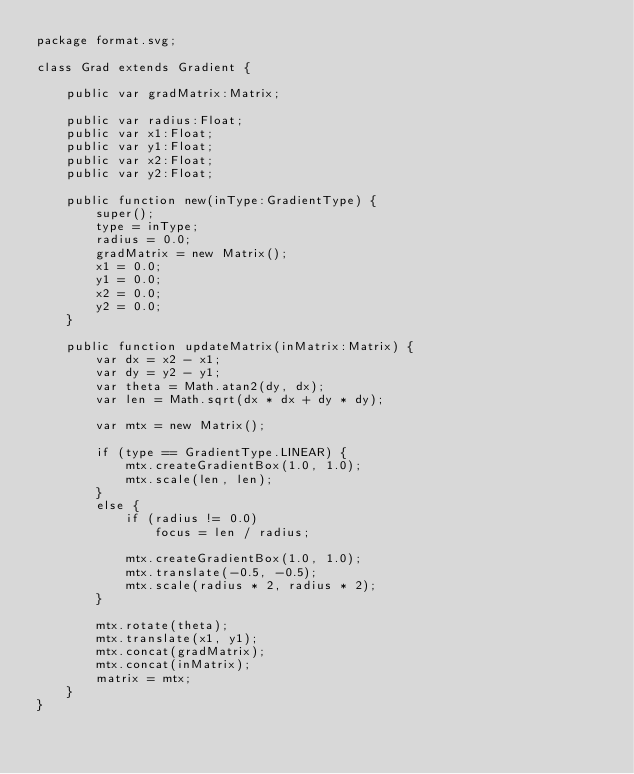Convert code to text. <code><loc_0><loc_0><loc_500><loc_500><_Haxe_>package format.svg;

class Grad extends Gradient {

	public var gradMatrix:Matrix;

	public var radius:Float;
	public var x1:Float;
	public var y1:Float;
	public var x2:Float;
	public var y2:Float;

	public function new(inType:GradientType) {
		super();
		type = inType;
		radius = 0.0;
		gradMatrix = new Matrix();
		x1 = 0.0;
		y1 = 0.0;
		x2 = 0.0;
		y2 = 0.0;
	}

	public function updateMatrix(inMatrix:Matrix) {
		var dx = x2 - x1;
		var dy = y2 - y1;
		var theta = Math.atan2(dy, dx);
		var len = Math.sqrt(dx * dx + dy * dy);

		var mtx = new Matrix();

		if (type == GradientType.LINEAR) {
			mtx.createGradientBox(1.0, 1.0);
			mtx.scale(len, len);
		}
		else {
			if (radius != 0.0)
				focus = len / radius;

			mtx.createGradientBox(1.0, 1.0);
			mtx.translate(-0.5, -0.5);
			mtx.scale(radius * 2, radius * 2);
		}

		mtx.rotate(theta);
		mtx.translate(x1, y1);
		mtx.concat(gradMatrix);
		mtx.concat(inMatrix);
		matrix = mtx;
	}
}</code> 